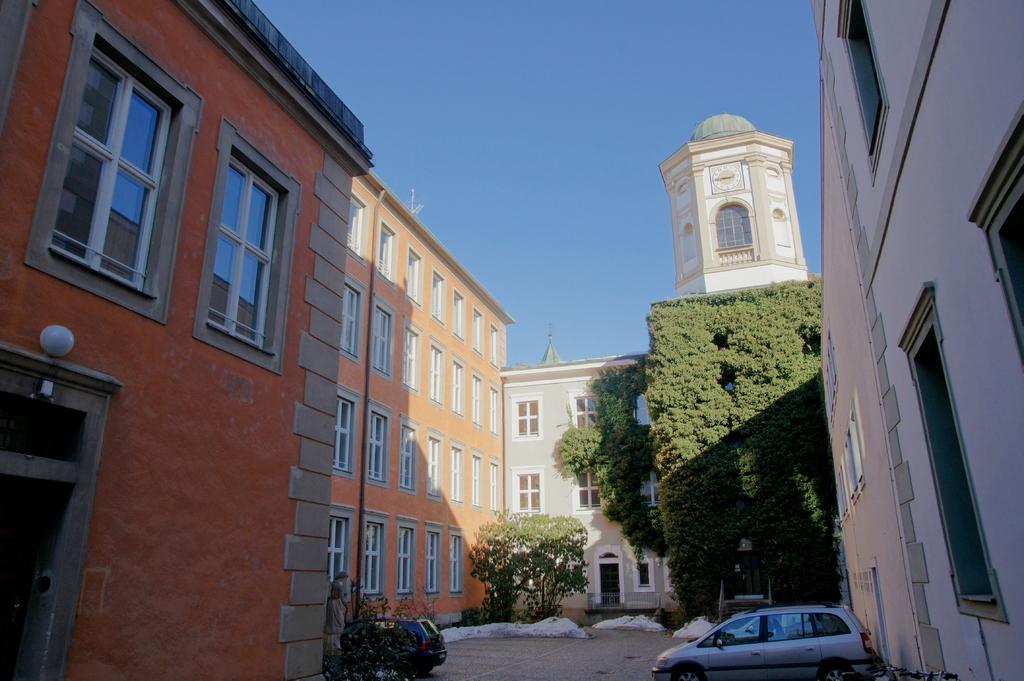Please provide a concise description of this image. This is an outside view. At the bottom there are two cars on the ground. In this image I can see few buildings and trees. At the top of the image I can see the sky in blue color. 